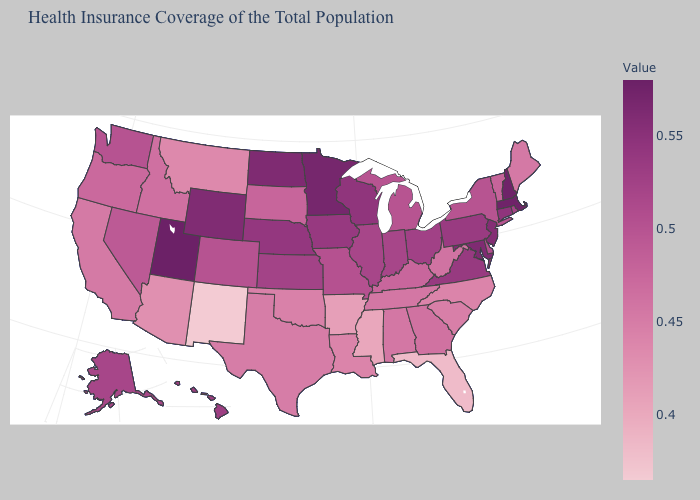Which states hav the highest value in the West?
Short answer required. Utah. Which states have the lowest value in the MidWest?
Concise answer only. South Dakota. Which states have the highest value in the USA?
Answer briefly. Utah. Among the states that border Maryland , which have the lowest value?
Keep it brief. West Virginia. Which states hav the highest value in the South?
Short answer required. Maryland. Is the legend a continuous bar?
Answer briefly. Yes. Among the states that border Arizona , does Nevada have the lowest value?
Quick response, please. No. Among the states that border Tennessee , which have the lowest value?
Give a very brief answer. Mississippi. 